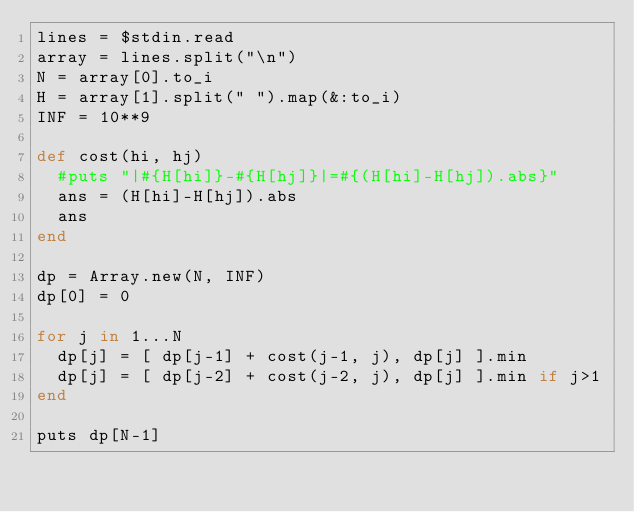Convert code to text. <code><loc_0><loc_0><loc_500><loc_500><_Ruby_>lines = $stdin.read
array = lines.split("\n")
N = array[0].to_i
H = array[1].split(" ").map(&:to_i)
INF = 10**9

def cost(hi, hj)
  #puts "|#{H[hi]}-#{H[hj]}|=#{(H[hi]-H[hj]).abs}"
  ans = (H[hi]-H[hj]).abs
  ans
end

dp = Array.new(N, INF)
dp[0] = 0

for j in 1...N
  dp[j] = [ dp[j-1] + cost(j-1, j), dp[j] ].min
  dp[j] = [ dp[j-2] + cost(j-2, j), dp[j] ].min if j>1
end

puts dp[N-1]
</code> 